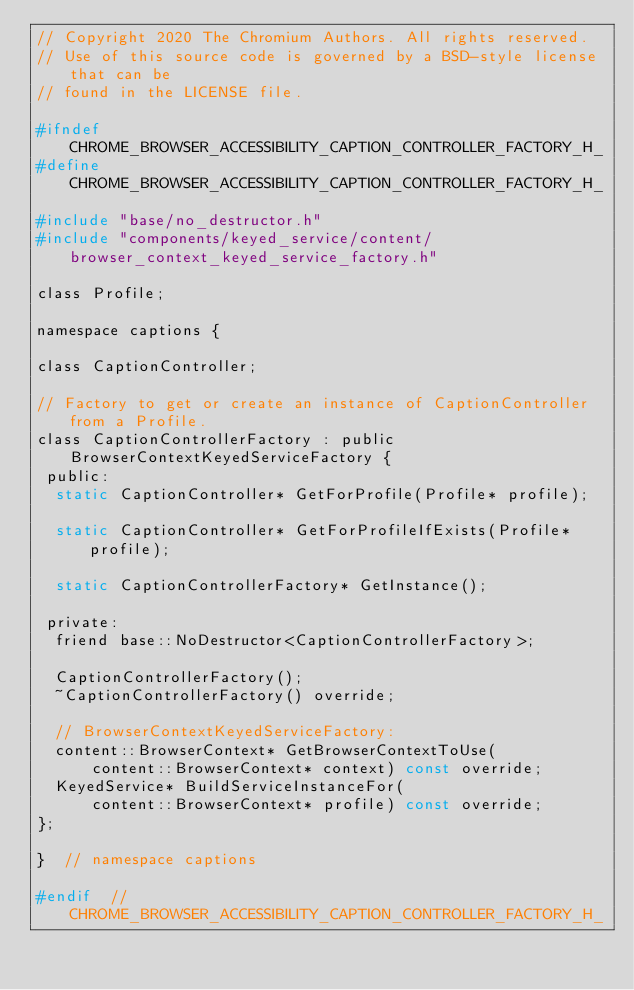<code> <loc_0><loc_0><loc_500><loc_500><_C_>// Copyright 2020 The Chromium Authors. All rights reserved.
// Use of this source code is governed by a BSD-style license that can be
// found in the LICENSE file.

#ifndef CHROME_BROWSER_ACCESSIBILITY_CAPTION_CONTROLLER_FACTORY_H_
#define CHROME_BROWSER_ACCESSIBILITY_CAPTION_CONTROLLER_FACTORY_H_

#include "base/no_destructor.h"
#include "components/keyed_service/content/browser_context_keyed_service_factory.h"

class Profile;

namespace captions {

class CaptionController;

// Factory to get or create an instance of CaptionController from a Profile.
class CaptionControllerFactory : public BrowserContextKeyedServiceFactory {
 public:
  static CaptionController* GetForProfile(Profile* profile);

  static CaptionController* GetForProfileIfExists(Profile* profile);

  static CaptionControllerFactory* GetInstance();

 private:
  friend base::NoDestructor<CaptionControllerFactory>;

  CaptionControllerFactory();
  ~CaptionControllerFactory() override;

  // BrowserContextKeyedServiceFactory:
  content::BrowserContext* GetBrowserContextToUse(
      content::BrowserContext* context) const override;
  KeyedService* BuildServiceInstanceFor(
      content::BrowserContext* profile) const override;
};

}  // namespace captions

#endif  // CHROME_BROWSER_ACCESSIBILITY_CAPTION_CONTROLLER_FACTORY_H_
</code> 